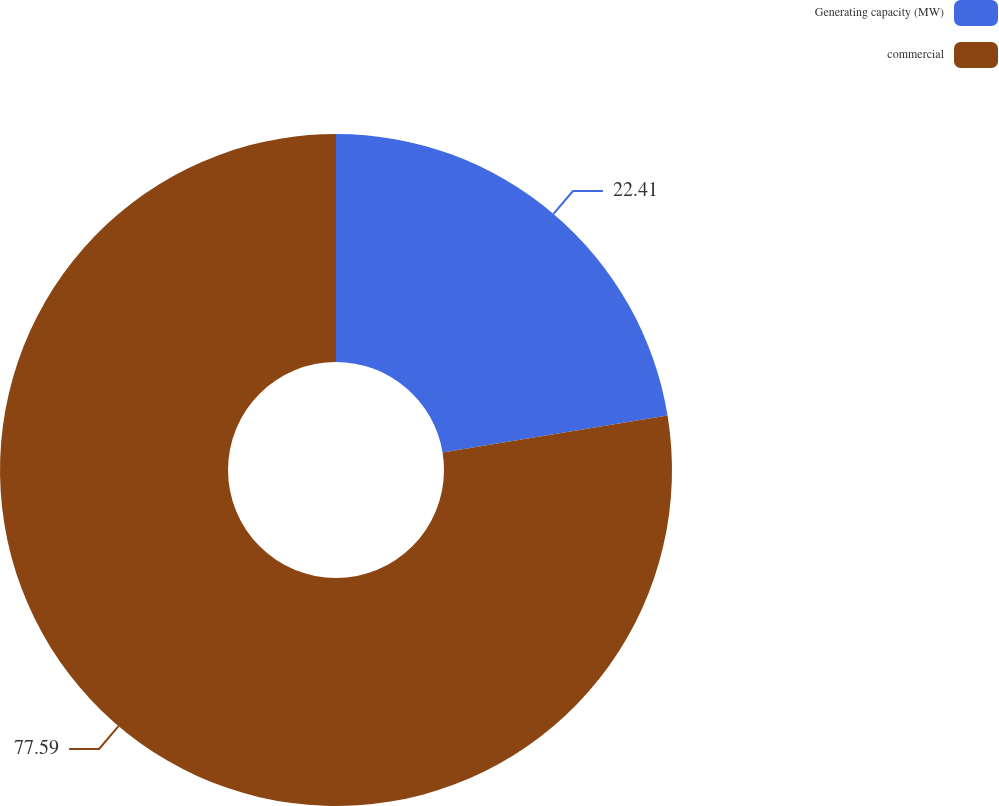<chart> <loc_0><loc_0><loc_500><loc_500><pie_chart><fcel>Generating capacity (MW)<fcel>commercial<nl><fcel>22.41%<fcel>77.59%<nl></chart> 